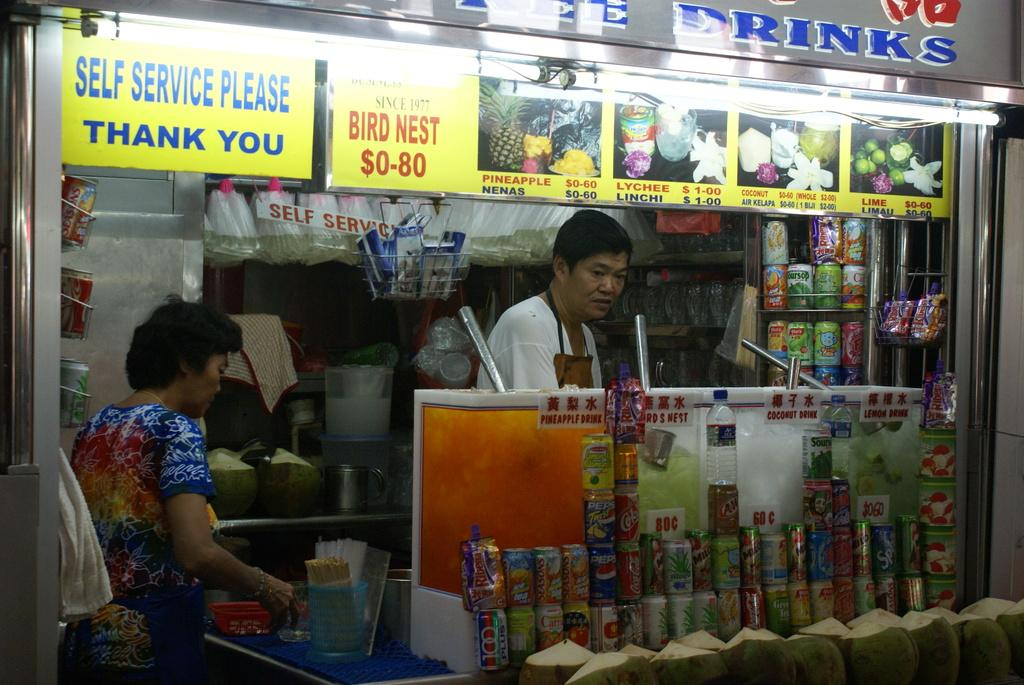<image>
Share a concise interpretation of the image provided. Man working behidn a stall that says Drinks on it. 